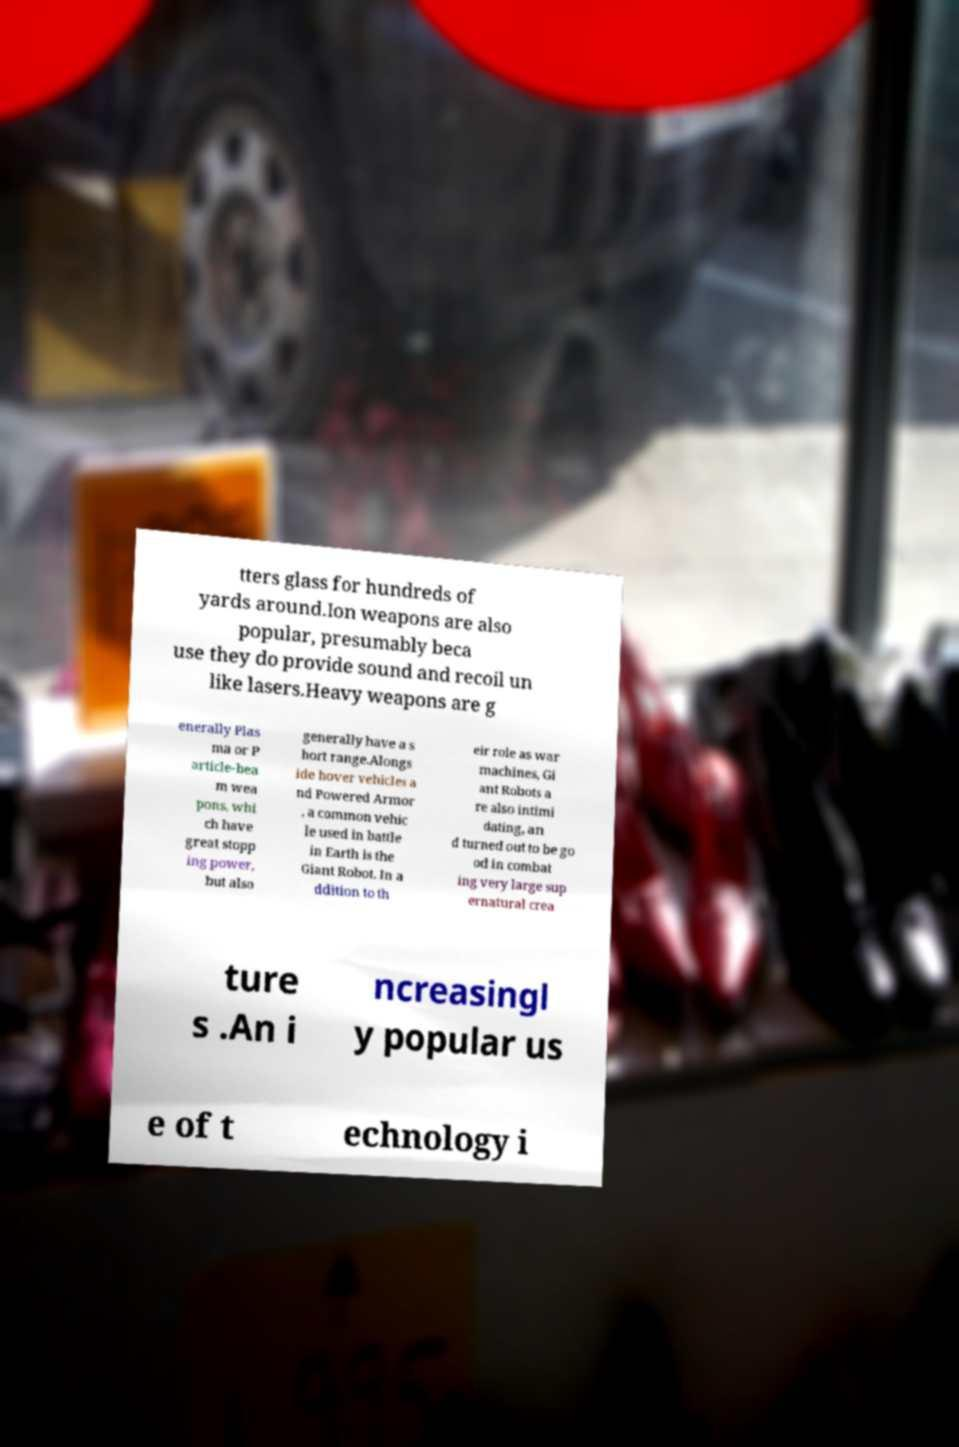For documentation purposes, I need the text within this image transcribed. Could you provide that? tters glass for hundreds of yards around.Ion weapons are also popular, presumably beca use they do provide sound and recoil un like lasers.Heavy weapons are g enerally Plas ma or P article-bea m wea pons, whi ch have great stopp ing power, but also generally have a s hort range.Alongs ide hover vehicles a nd Powered Armor , a common vehic le used in battle in Earth is the Giant Robot. In a ddition to th eir role as war machines, Gi ant Robots a re also intimi dating, an d turned out to be go od in combat ing very large sup ernatural crea ture s .An i ncreasingl y popular us e of t echnology i 